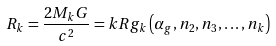Convert formula to latex. <formula><loc_0><loc_0><loc_500><loc_500>R _ { k } = \frac { 2 M _ { k } G } { c ^ { 2 } } = k R g _ { k } \left ( \alpha _ { g } , n _ { 2 } , n _ { 3 } , \dots , n _ { k } \right )</formula> 